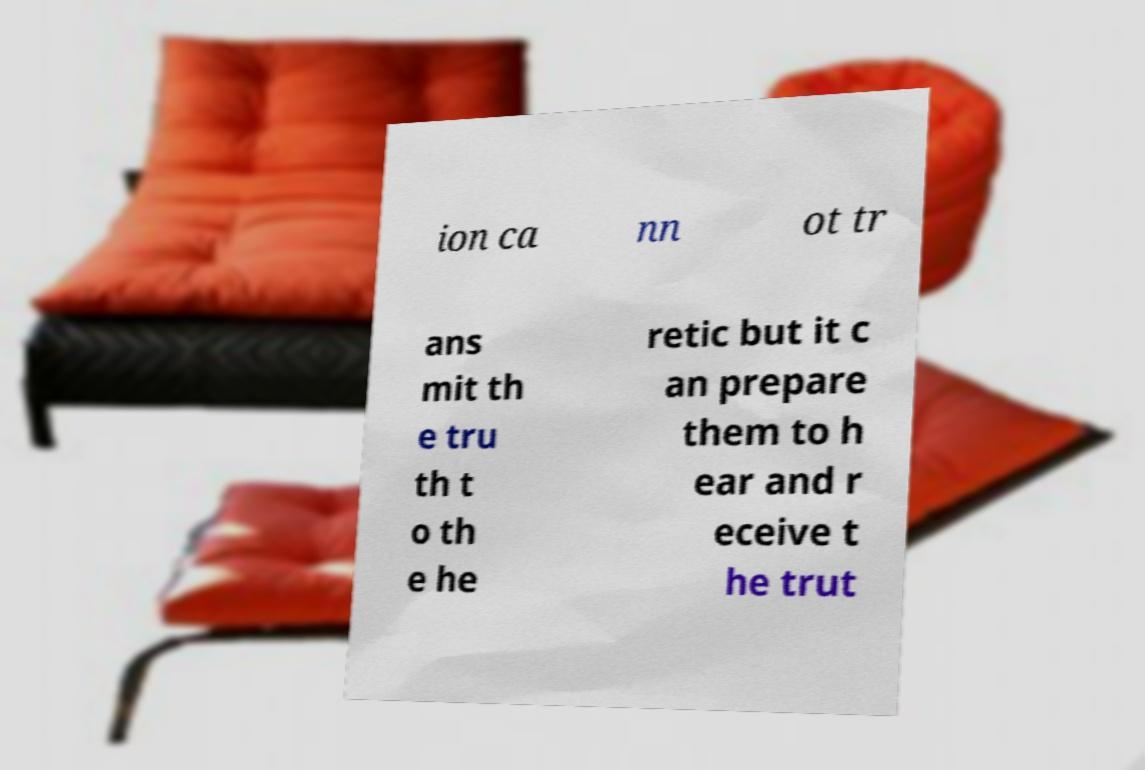Please read and relay the text visible in this image. What does it say? ion ca nn ot tr ans mit th e tru th t o th e he retic but it c an prepare them to h ear and r eceive t he trut 